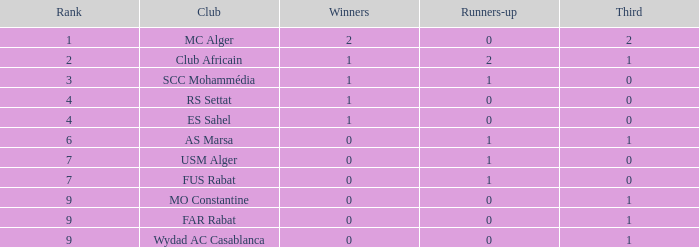What is the rank that has both a third of 2 and winners with values under 2? None. 